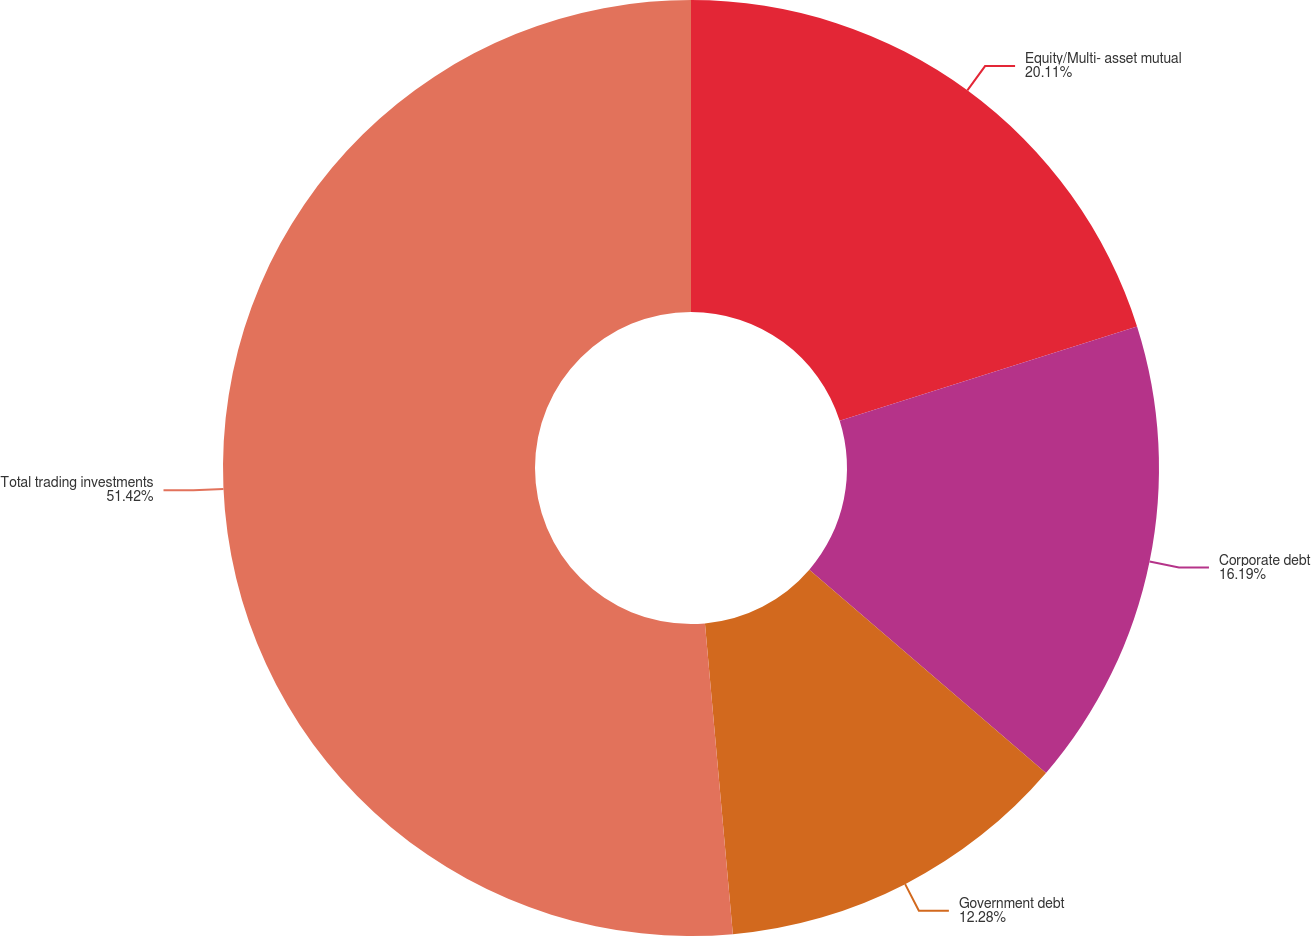Convert chart to OTSL. <chart><loc_0><loc_0><loc_500><loc_500><pie_chart><fcel>Equity/Multi- asset mutual<fcel>Corporate debt<fcel>Government debt<fcel>Total trading investments<nl><fcel>20.11%<fcel>16.19%<fcel>12.28%<fcel>51.43%<nl></chart> 